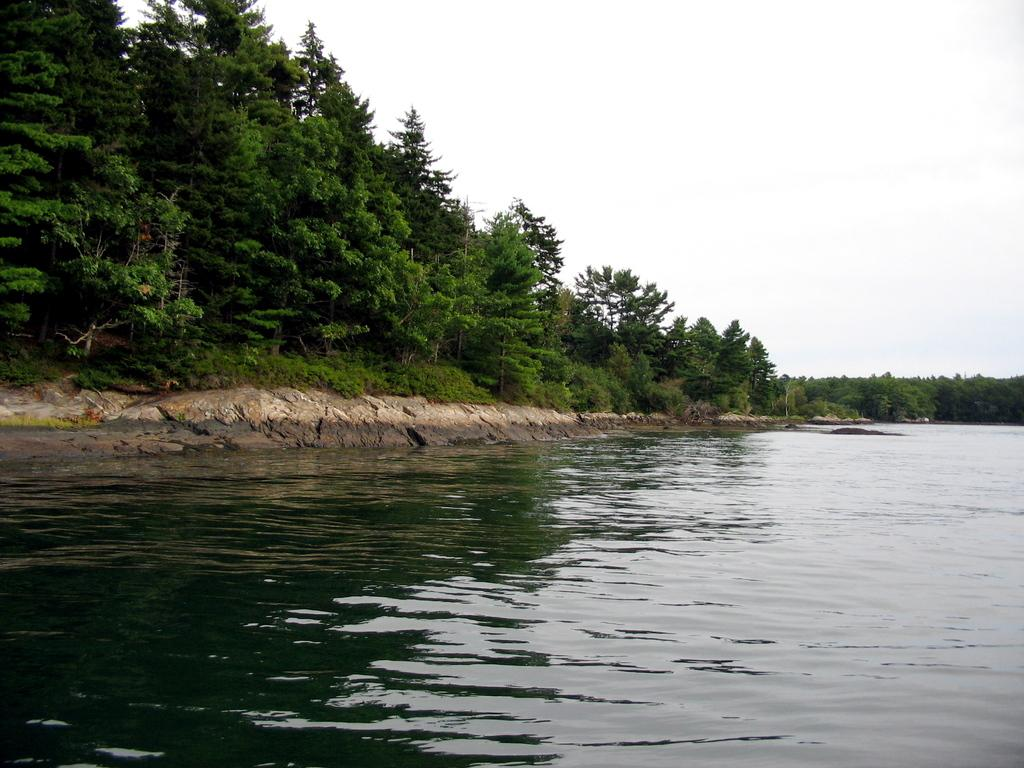What is the main feature in the foreground of the image? There is a water body in the foreground of the image. What can be seen on the left side of the image? There are trees and plants on the left side of the image. What is visible in the background towards the right side of the image? There are trees in the background towards the right side of the image. What is visible at the top of the image? The sky is visible at the top of the image. Can you see a mask floating on the water body in the image? There is no mask present in the image. Is there a cover over the water body in the image? There is no cover visible over the water body in the image. 